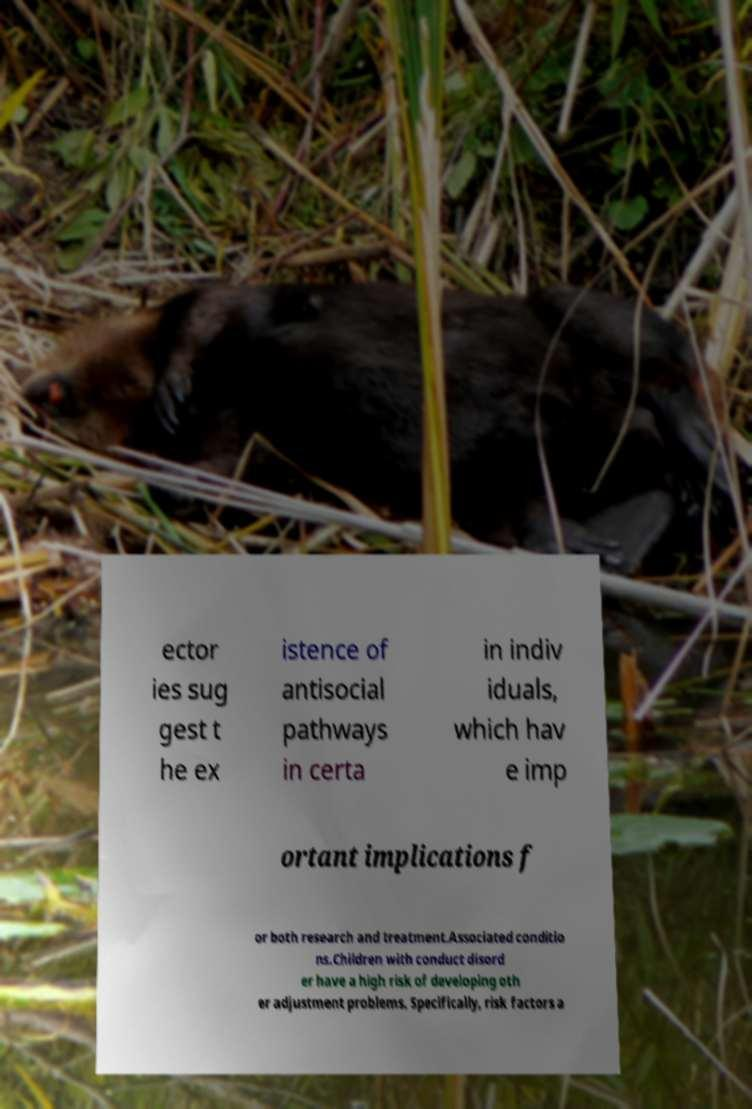Could you extract and type out the text from this image? ector ies sug gest t he ex istence of antisocial pathways in certa in indiv iduals, which hav e imp ortant implications f or both research and treatment.Associated conditio ns.Children with conduct disord er have a high risk of developing oth er adjustment problems. Specifically, risk factors a 